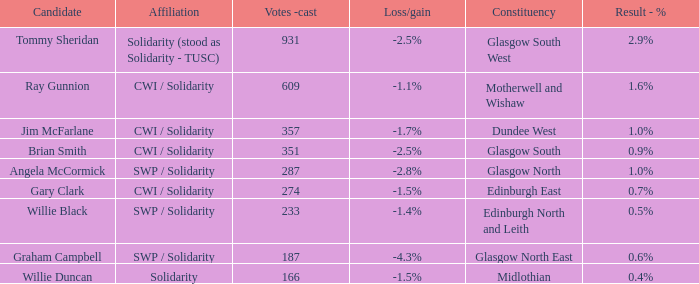What was the loss/gain when the affiliation was solidarity? -1.5%. 